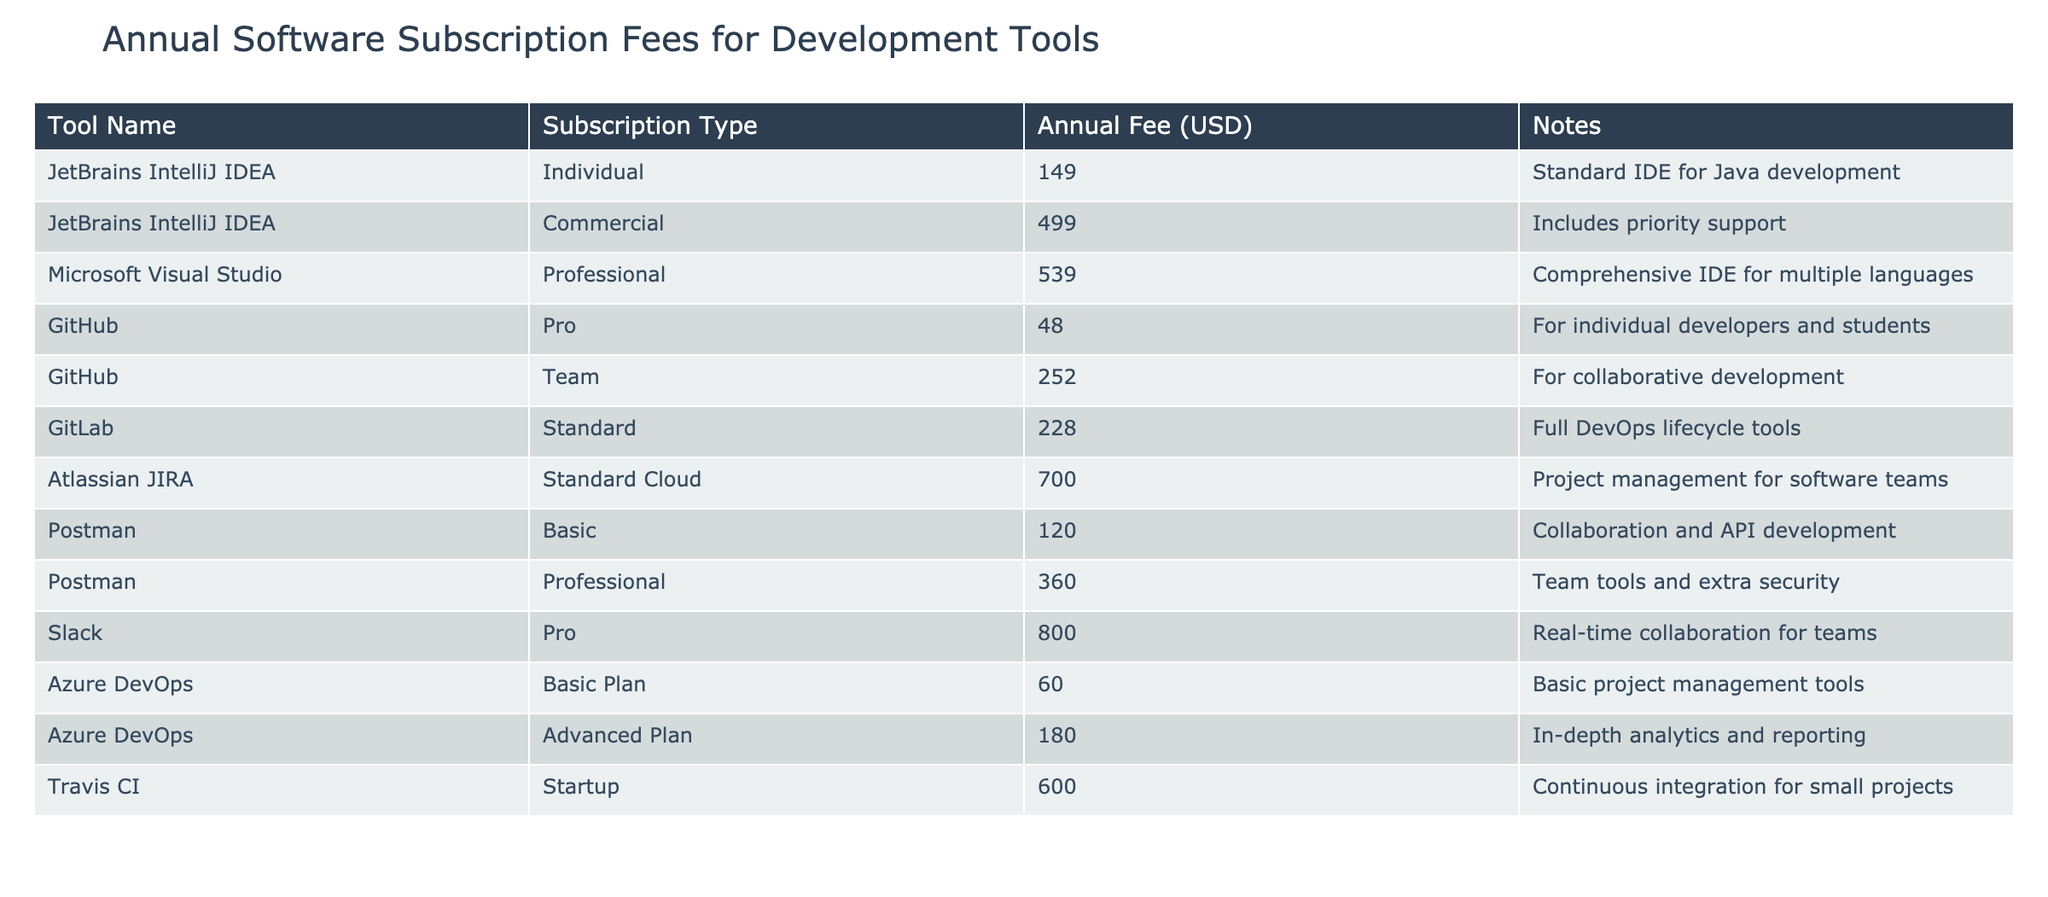What is the annual fee for GitHub Pro subscription? The table lists GitHub Pro under the "Tool Name" column, showing its subscription type as "Pro" with an annual fee of 48.00 USD. Thus, you can directly retrieve this information from the table without any calculations.
Answer: 48.00 USD How much is the difference between Azure DevOps Advanced Plan and the JetBrains IntelliJ IDEA Commercial plan? First, identify the annual fee for Azure DevOps Advanced Plan, which is 180.00 USD. Then, find the fee for JetBrains IntelliJ IDEA Commercial, which is 499.00 USD. The difference is calculated by subtracting Azure DevOps from JetBrains IntelliJ IDEA: 499.00 - 180.00 = 319.00 USD.
Answer: 319.00 USD Is Slack's subscription fee higher than Atlassian JIRA's subscription fee? The table shows Slack's annual fee as 800.00 USD and Atlassian JIRA's fee as 700.00 USD. Since 800.00 is greater than 700.00, the answer is yes.
Answer: Yes What is the total annual fee for all subscription types of Postman? Postman has two subscription types: Basic at 120.00 USD and Professional at 360.00 USD. To find the total, add both fees together: 120.00 + 360.00 = 480.00 USD.
Answer: 480.00 USD Which subscription type has the highest annual fee? To find the highest fee, examine all annual fees listed in the table. The highest value is 800.00 USD for Slack Pro subscription. Therefore, Slack Pro has the highest annual fee.
Answer: Slack Pro What is the average annual fee for tools provided by GitHub? GitHub has two subscriptions: Pro (48.00 USD) and Team (252.00 USD). The average is calculated by summing the fees (48.00 + 252.00 = 300.00 USD) and dividing by the number of subscriptions (2): 300.00 / 2 = 150.00 USD.
Answer: 150.00 USD Is the annual fee for Microsoft Visual Studio Professional less than 500.00 USD? The annual fee for Microsoft Visual Studio Professional, according to the table, is 539.00 USD, which is greater than 500.00 USD, therefore the answer is no.
Answer: No Which tool offers the lowest annual fee and what is it? By reviewing the annual fees from all tools, GitHub Pro has the lowest fee at 48.00 USD. This makes it the subscription with the lowest charge.
Answer: 48.00 USD 